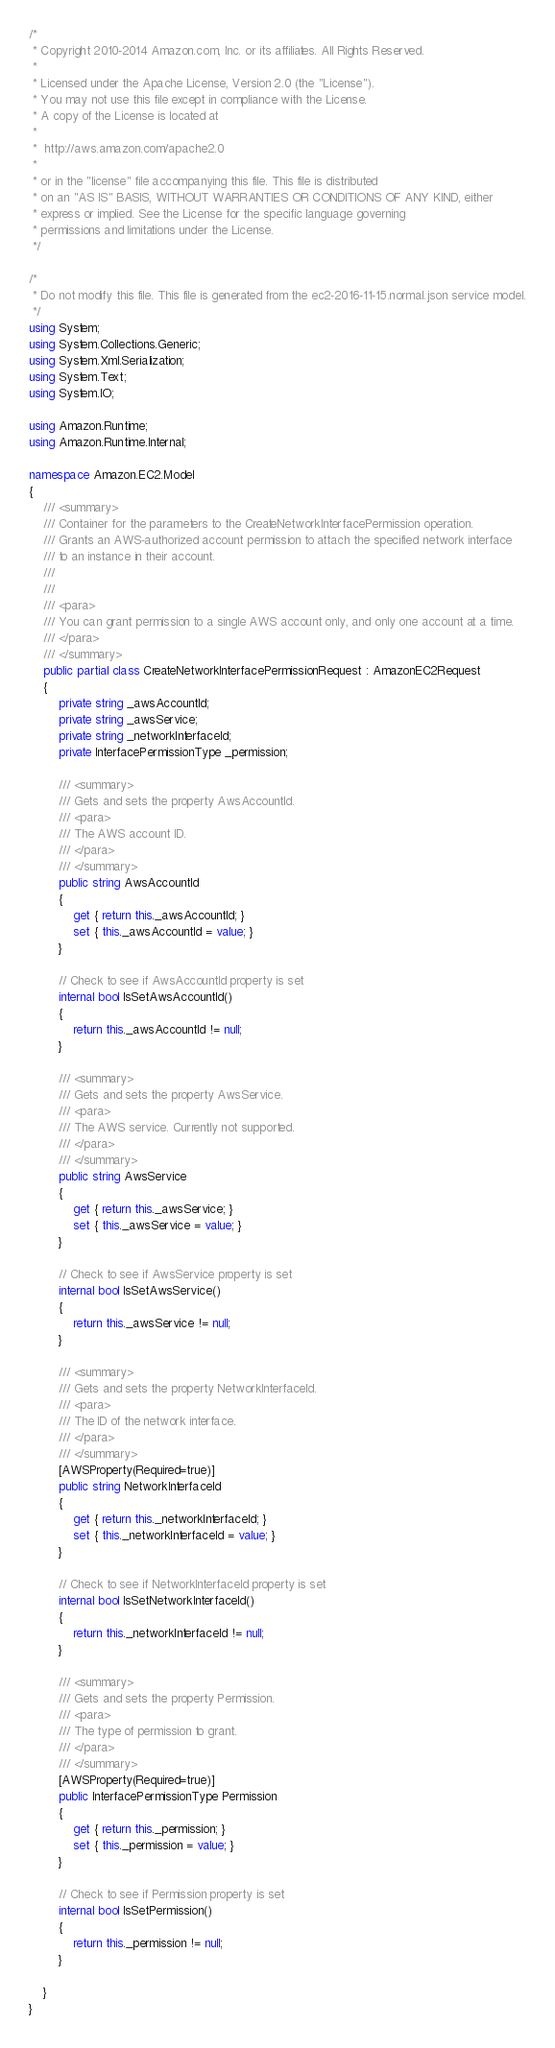Convert code to text. <code><loc_0><loc_0><loc_500><loc_500><_C#_>/*
 * Copyright 2010-2014 Amazon.com, Inc. or its affiliates. All Rights Reserved.
 * 
 * Licensed under the Apache License, Version 2.0 (the "License").
 * You may not use this file except in compliance with the License.
 * A copy of the License is located at
 * 
 *  http://aws.amazon.com/apache2.0
 * 
 * or in the "license" file accompanying this file. This file is distributed
 * on an "AS IS" BASIS, WITHOUT WARRANTIES OR CONDITIONS OF ANY KIND, either
 * express or implied. See the License for the specific language governing
 * permissions and limitations under the License.
 */

/*
 * Do not modify this file. This file is generated from the ec2-2016-11-15.normal.json service model.
 */
using System;
using System.Collections.Generic;
using System.Xml.Serialization;
using System.Text;
using System.IO;

using Amazon.Runtime;
using Amazon.Runtime.Internal;

namespace Amazon.EC2.Model
{
    /// <summary>
    /// Container for the parameters to the CreateNetworkInterfacePermission operation.
    /// Grants an AWS-authorized account permission to attach the specified network interface
    /// to an instance in their account.
    /// 
    ///  
    /// <para>
    /// You can grant permission to a single AWS account only, and only one account at a time.
    /// </para>
    /// </summary>
    public partial class CreateNetworkInterfacePermissionRequest : AmazonEC2Request
    {
        private string _awsAccountId;
        private string _awsService;
        private string _networkInterfaceId;
        private InterfacePermissionType _permission;

        /// <summary>
        /// Gets and sets the property AwsAccountId. 
        /// <para>
        /// The AWS account ID.
        /// </para>
        /// </summary>
        public string AwsAccountId
        {
            get { return this._awsAccountId; }
            set { this._awsAccountId = value; }
        }

        // Check to see if AwsAccountId property is set
        internal bool IsSetAwsAccountId()
        {
            return this._awsAccountId != null;
        }

        /// <summary>
        /// Gets and sets the property AwsService. 
        /// <para>
        /// The AWS service. Currently not supported.
        /// </para>
        /// </summary>
        public string AwsService
        {
            get { return this._awsService; }
            set { this._awsService = value; }
        }

        // Check to see if AwsService property is set
        internal bool IsSetAwsService()
        {
            return this._awsService != null;
        }

        /// <summary>
        /// Gets and sets the property NetworkInterfaceId. 
        /// <para>
        /// The ID of the network interface.
        /// </para>
        /// </summary>
        [AWSProperty(Required=true)]
        public string NetworkInterfaceId
        {
            get { return this._networkInterfaceId; }
            set { this._networkInterfaceId = value; }
        }

        // Check to see if NetworkInterfaceId property is set
        internal bool IsSetNetworkInterfaceId()
        {
            return this._networkInterfaceId != null;
        }

        /// <summary>
        /// Gets and sets the property Permission. 
        /// <para>
        /// The type of permission to grant.
        /// </para>
        /// </summary>
        [AWSProperty(Required=true)]
        public InterfacePermissionType Permission
        {
            get { return this._permission; }
            set { this._permission = value; }
        }

        // Check to see if Permission property is set
        internal bool IsSetPermission()
        {
            return this._permission != null;
        }

    }
}</code> 